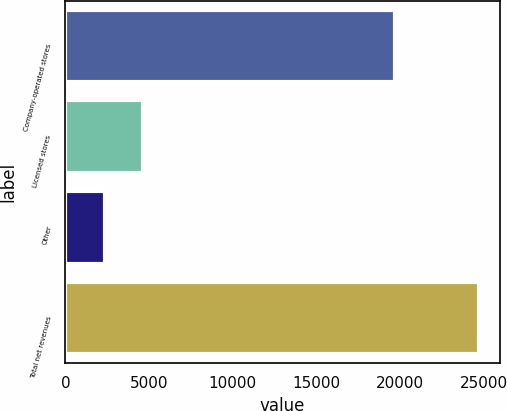Convert chart. <chart><loc_0><loc_0><loc_500><loc_500><bar_chart><fcel>Company-operated stores<fcel>Licensed stores<fcel>Other<fcel>Total net revenues<nl><fcel>19690.3<fcel>4611.25<fcel>2377<fcel>24719.5<nl></chart> 